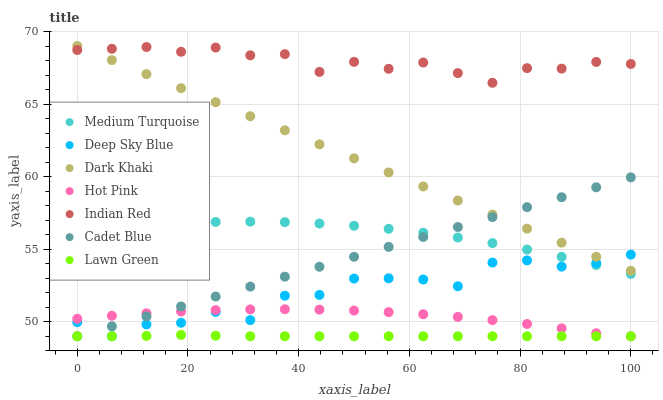Does Lawn Green have the minimum area under the curve?
Answer yes or no. Yes. Does Indian Red have the maximum area under the curve?
Answer yes or no. Yes. Does Medium Turquoise have the minimum area under the curve?
Answer yes or no. No. Does Medium Turquoise have the maximum area under the curve?
Answer yes or no. No. Is Dark Khaki the smoothest?
Answer yes or no. Yes. Is Deep Sky Blue the roughest?
Answer yes or no. Yes. Is Medium Turquoise the smoothest?
Answer yes or no. No. Is Medium Turquoise the roughest?
Answer yes or no. No. Does Lawn Green have the lowest value?
Answer yes or no. Yes. Does Medium Turquoise have the lowest value?
Answer yes or no. No. Does Dark Khaki have the highest value?
Answer yes or no. Yes. Does Medium Turquoise have the highest value?
Answer yes or no. No. Is Cadet Blue less than Indian Red?
Answer yes or no. Yes. Is Indian Red greater than Cadet Blue?
Answer yes or no. Yes. Does Medium Turquoise intersect Cadet Blue?
Answer yes or no. Yes. Is Medium Turquoise less than Cadet Blue?
Answer yes or no. No. Is Medium Turquoise greater than Cadet Blue?
Answer yes or no. No. Does Cadet Blue intersect Indian Red?
Answer yes or no. No. 